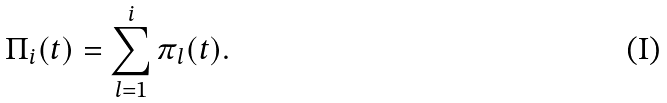<formula> <loc_0><loc_0><loc_500><loc_500>\Pi _ { i } ( t ) = \sum _ { l = 1 } ^ { i } \pi _ { l } ( t ) .</formula> 